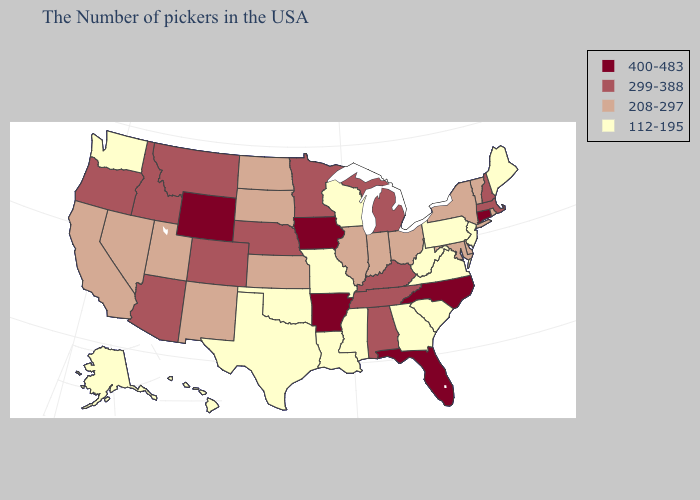What is the highest value in states that border South Carolina?
Keep it brief. 400-483. Does Connecticut have the highest value in the Northeast?
Be succinct. Yes. Name the states that have a value in the range 400-483?
Write a very short answer. Connecticut, North Carolina, Florida, Arkansas, Iowa, Wyoming. Name the states that have a value in the range 112-195?
Give a very brief answer. Maine, New Jersey, Pennsylvania, Virginia, South Carolina, West Virginia, Georgia, Wisconsin, Mississippi, Louisiana, Missouri, Oklahoma, Texas, Washington, Alaska, Hawaii. Name the states that have a value in the range 208-297?
Quick response, please. Rhode Island, Vermont, New York, Delaware, Maryland, Ohio, Indiana, Illinois, Kansas, South Dakota, North Dakota, New Mexico, Utah, Nevada, California. What is the value of North Dakota?
Concise answer only. 208-297. Among the states that border Virginia , does West Virginia have the lowest value?
Quick response, please. Yes. Name the states that have a value in the range 208-297?
Keep it brief. Rhode Island, Vermont, New York, Delaware, Maryland, Ohio, Indiana, Illinois, Kansas, South Dakota, North Dakota, New Mexico, Utah, Nevada, California. What is the lowest value in the West?
Write a very short answer. 112-195. What is the value of New York?
Write a very short answer. 208-297. Among the states that border Colorado , which have the lowest value?
Keep it brief. Oklahoma. Name the states that have a value in the range 400-483?
Concise answer only. Connecticut, North Carolina, Florida, Arkansas, Iowa, Wyoming. What is the value of New Jersey?
Be succinct. 112-195. What is the value of Hawaii?
Give a very brief answer. 112-195. Name the states that have a value in the range 208-297?
Keep it brief. Rhode Island, Vermont, New York, Delaware, Maryland, Ohio, Indiana, Illinois, Kansas, South Dakota, North Dakota, New Mexico, Utah, Nevada, California. 